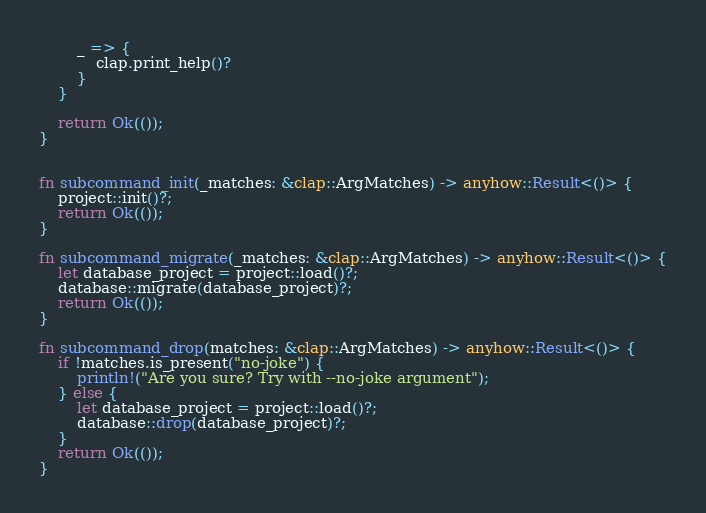Convert code to text. <code><loc_0><loc_0><loc_500><loc_500><_Rust_>        _ => {
            clap.print_help()?
        }
    }

    return Ok(());
}


fn subcommand_init(_matches: &clap::ArgMatches) -> anyhow::Result<()> {
    project::init()?;
    return Ok(());
}

fn subcommand_migrate(_matches: &clap::ArgMatches) -> anyhow::Result<()> {
    let database_project = project::load()?;
    database::migrate(database_project)?;
    return Ok(());
}

fn subcommand_drop(matches: &clap::ArgMatches) -> anyhow::Result<()> {
    if !matches.is_present("no-joke") {
        println!("Are you sure? Try with --no-joke argument");
    } else {
        let database_project = project::load()?;
        database::drop(database_project)?;
    }
    return Ok(());
}
</code> 